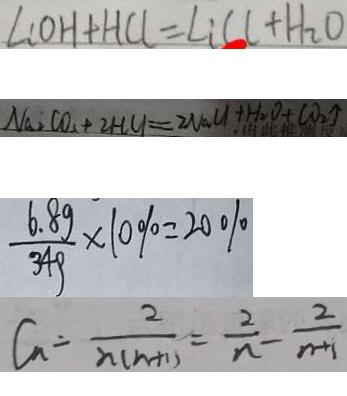Convert formula to latex. <formula><loc_0><loc_0><loc_500><loc_500>L C O H + H C l = L i C C + H _ { 2 } O 
 N a _ { 2 } C O _ { 2 } + 2 H C l = 2 N a C l + H _ { 2 } O + C O _ { 2 } \uparrow 
 \frac { 6 . 8 g } { 3 4 g } \times 1 0 \% = 2 0 \% 
 C _ { n } = \frac { 2 } { n ( n + 1 ) } = \frac { 2 } { n } - \frac { 2 } { n + 1 }</formula> 